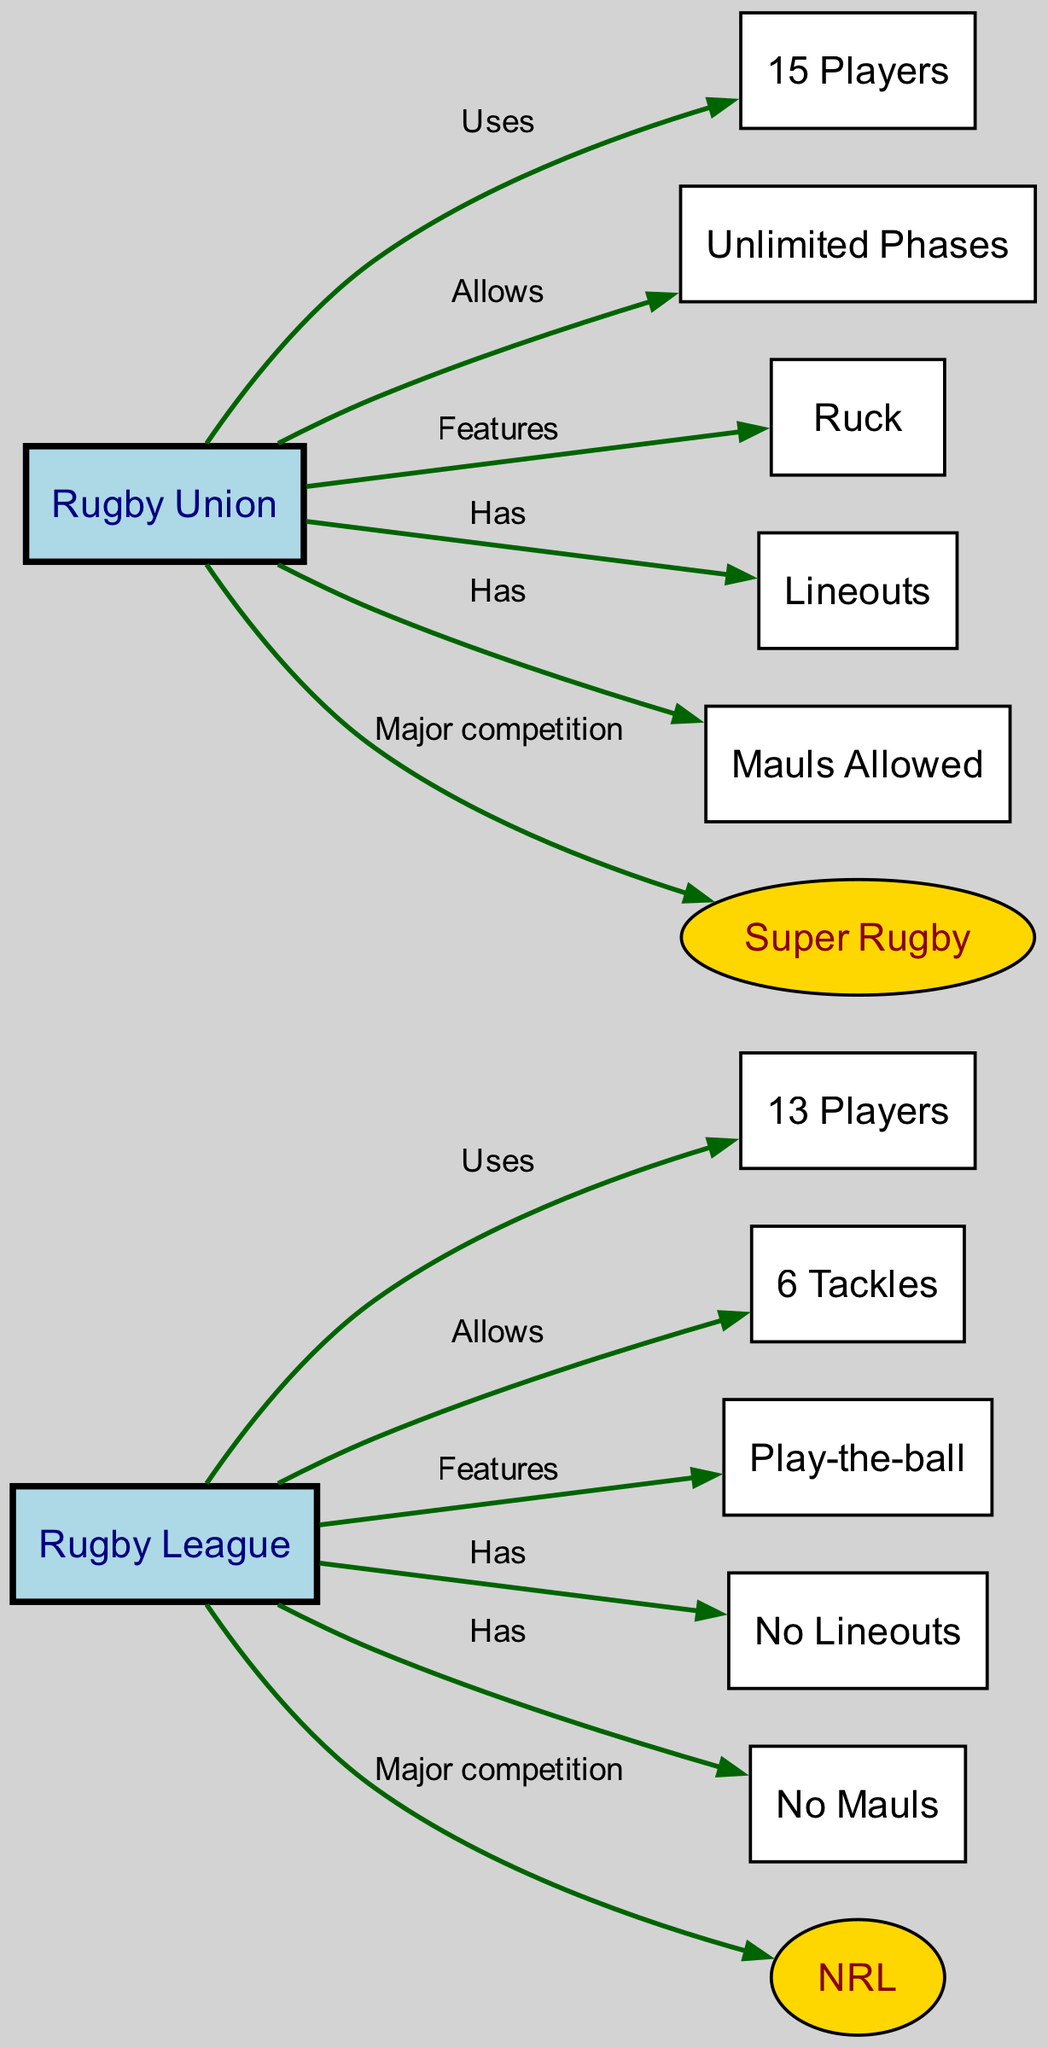What is the number of players in Rugby League? The diagram indicates that Rugby League is associated with "13 Players," as shown by the edge labeled "Uses."
Answer: 13 Players What is the major competition for Rugby Union? The edge leading from Rugby Union to Super Rugby is labeled "Major competition," indicating that this is the primary league for Rugby Union.
Answer: Super Rugby How many tackles are allowed in Rugby League? The directed edge from Rugby League to "6 Tackles" indicates that Rugby League has a limit of 6 tackles per possession.
Answer: 6 Tackles Which game feature is unique to Rugby Union? The presence of an edge from Rugby Union to "Ruck," while Rugby League does not have this feature, demonstrates that a ruck is unique to Rugby Union.
Answer: Ruck What distinguishes Rugby League from Rugby Union in terms of lineouts? The edge from Rugby League labeled "Has" indicates "No Lineouts," while the edge from Rugby Union indicates "Lineouts," showing the difference between the two games.
Answer: No Lineouts Does Rugby Union allow mauls? The edge connecting Rugby Union to "Mauls Allowed" demonstrates that Rugby Union permits mauls, while Rugby League does not allow them as indicated by "No Mauls."
Answer: Yes How many edges are present in the diagram? By counting all the directed connections between nodes, we find there are a total of 12 edges in the diagram.
Answer: 12 Which type of game requires more players on the field? The comparison between the nodes shows that Rugby Union, with "15 Players," has more players than Rugby League, which has "13 Players."
Answer: 15 Players What features do Rugby League and Rugby Union both share? The edges do not show any common features listed directly under them, indicating that Rugby League (Play-the-ball) and Rugby Union (Ruck) have distinct features with no overlap shown.
Answer: None 